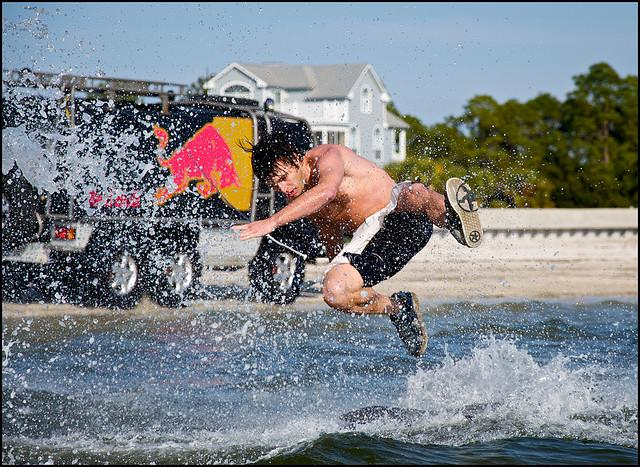What animal is the picture on the truck of? bull 